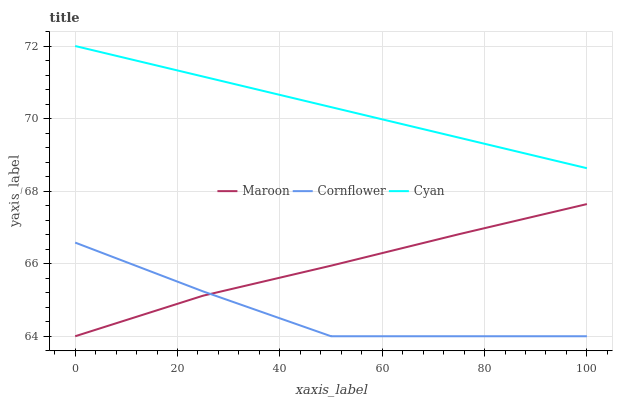Does Cornflower have the minimum area under the curve?
Answer yes or no. Yes. Does Cyan have the maximum area under the curve?
Answer yes or no. Yes. Does Maroon have the minimum area under the curve?
Answer yes or no. No. Does Maroon have the maximum area under the curve?
Answer yes or no. No. Is Cyan the smoothest?
Answer yes or no. Yes. Is Cornflower the roughest?
Answer yes or no. Yes. Is Maroon the smoothest?
Answer yes or no. No. Is Maroon the roughest?
Answer yes or no. No. Does Cyan have the lowest value?
Answer yes or no. No. Does Maroon have the highest value?
Answer yes or no. No. Is Maroon less than Cyan?
Answer yes or no. Yes. Is Cyan greater than Cornflower?
Answer yes or no. Yes. Does Maroon intersect Cyan?
Answer yes or no. No. 